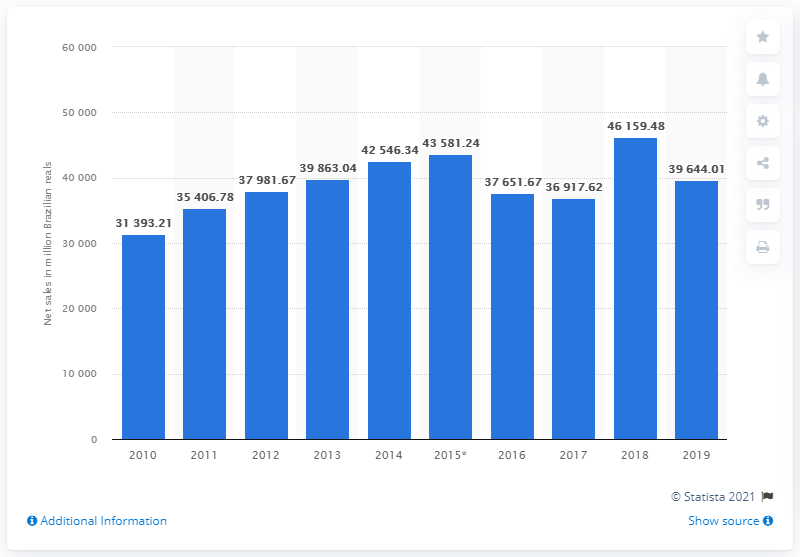Draw attention to some important aspects in this diagram. In 2019, the net sales of Gerdau S.A. were 39,644.01. 